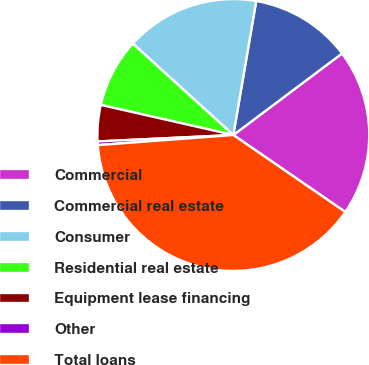Convert chart to OTSL. <chart><loc_0><loc_0><loc_500><loc_500><pie_chart><fcel>Commercial<fcel>Commercial real estate<fcel>Consumer<fcel>Residential real estate<fcel>Equipment lease financing<fcel>Other<fcel>Total loans<nl><fcel>19.83%<fcel>12.07%<fcel>15.95%<fcel>8.19%<fcel>4.31%<fcel>0.43%<fcel>39.23%<nl></chart> 